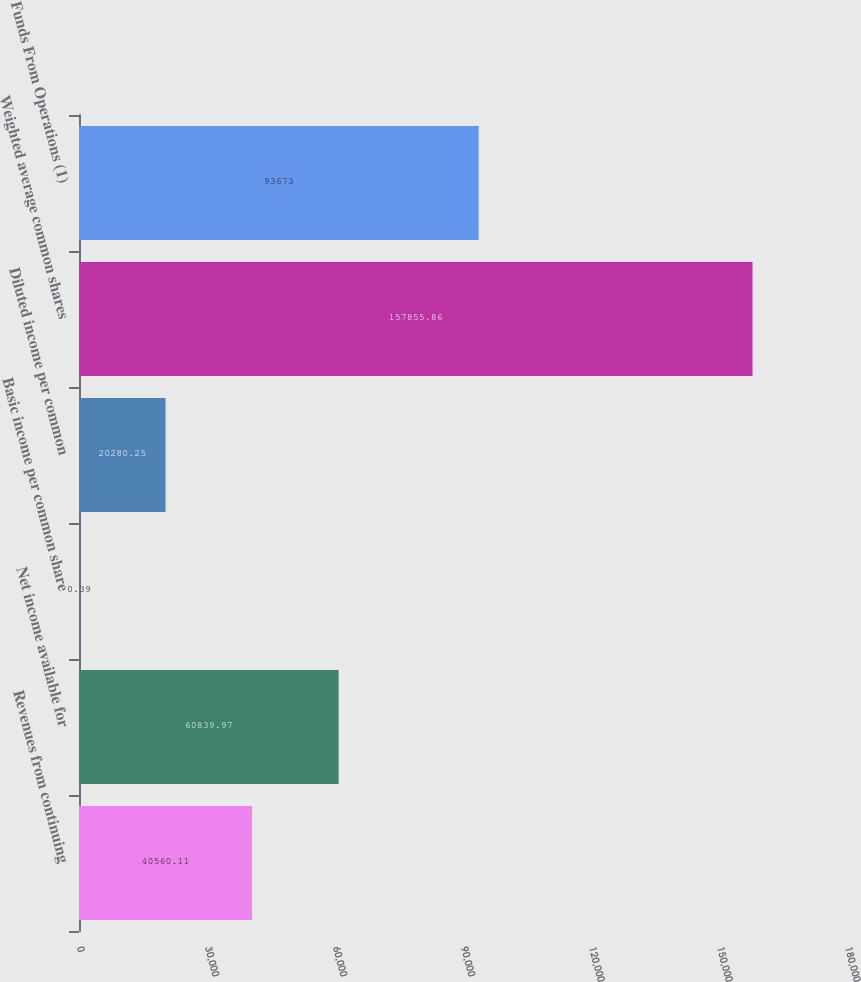Convert chart. <chart><loc_0><loc_0><loc_500><loc_500><bar_chart><fcel>Revenues from continuing<fcel>Net income available for<fcel>Basic income per common share<fcel>Diluted income per common<fcel>Weighted average common shares<fcel>Funds From Operations (1)<nl><fcel>40560.1<fcel>60840<fcel>0.39<fcel>20280.2<fcel>157856<fcel>93673<nl></chart> 